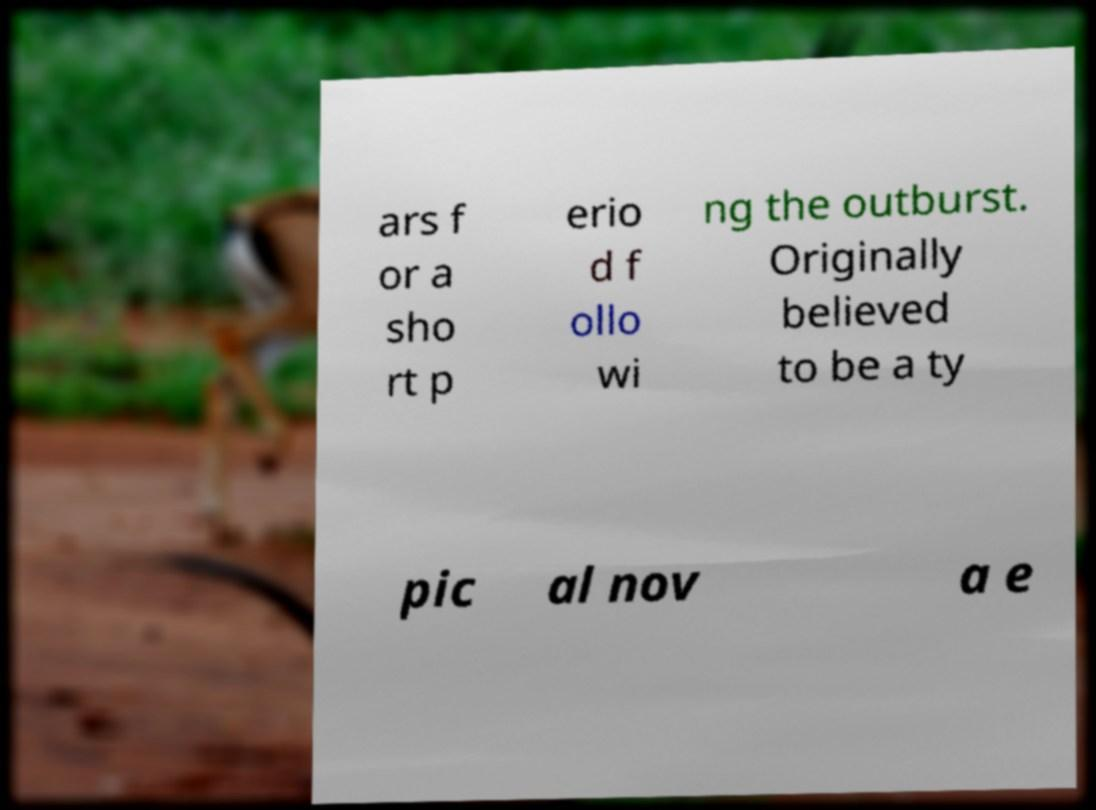For documentation purposes, I need the text within this image transcribed. Could you provide that? ars f or a sho rt p erio d f ollo wi ng the outburst. Originally believed to be a ty pic al nov a e 